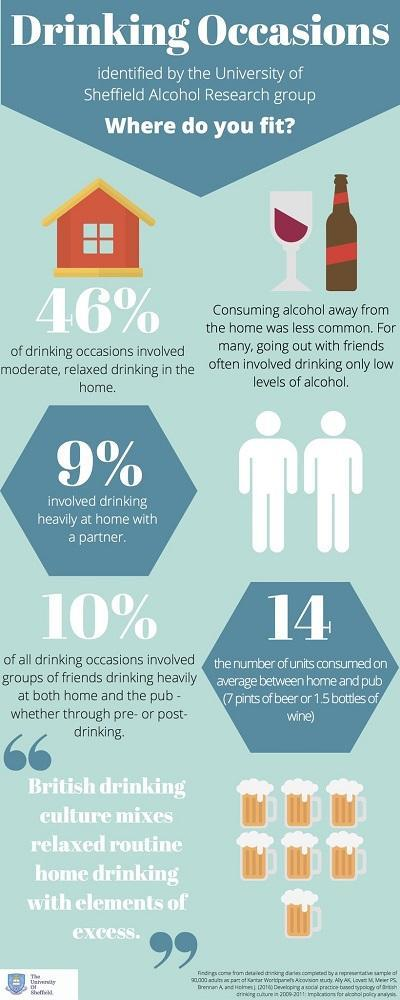How many beer mugs are shown in this infographic image?
Answer the question with a short phrase. 7 